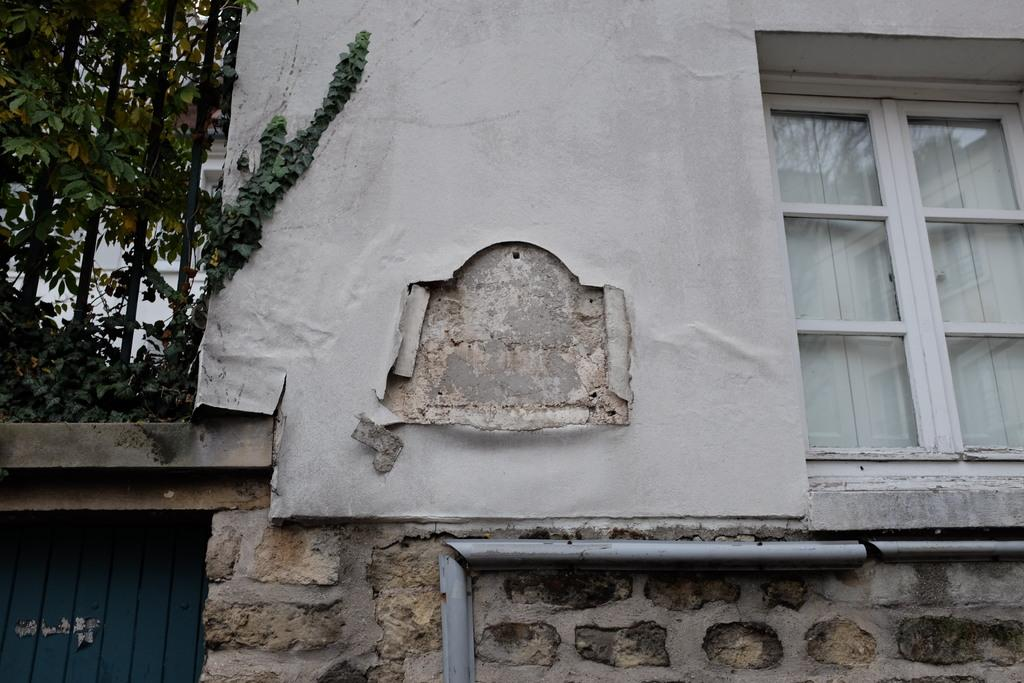What type of structure is visible in the image? There is a building in the image. Can you describe any specific features of the building? There is a window in the image, which is a feature of the building. What type of natural elements can be seen in the image? There are trees in the image. How many dogs are playing the drum in the image? There are no dogs or drums present in the image. 